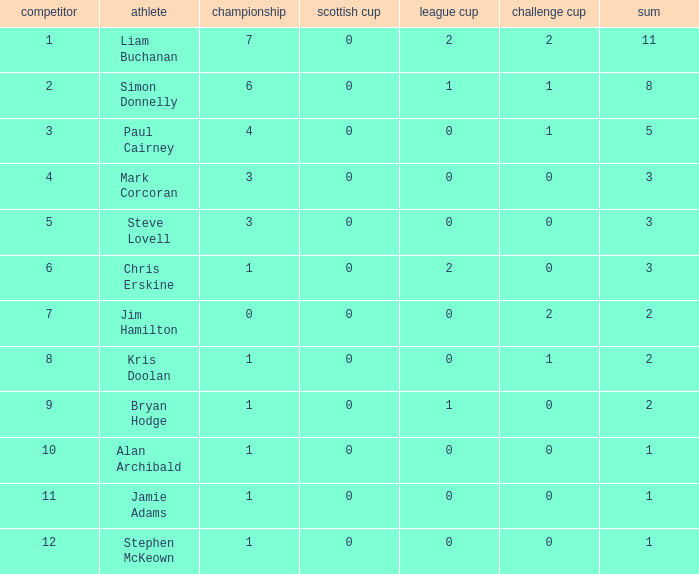In the challenge cup, how many points did player 7 achieve? 1.0. 